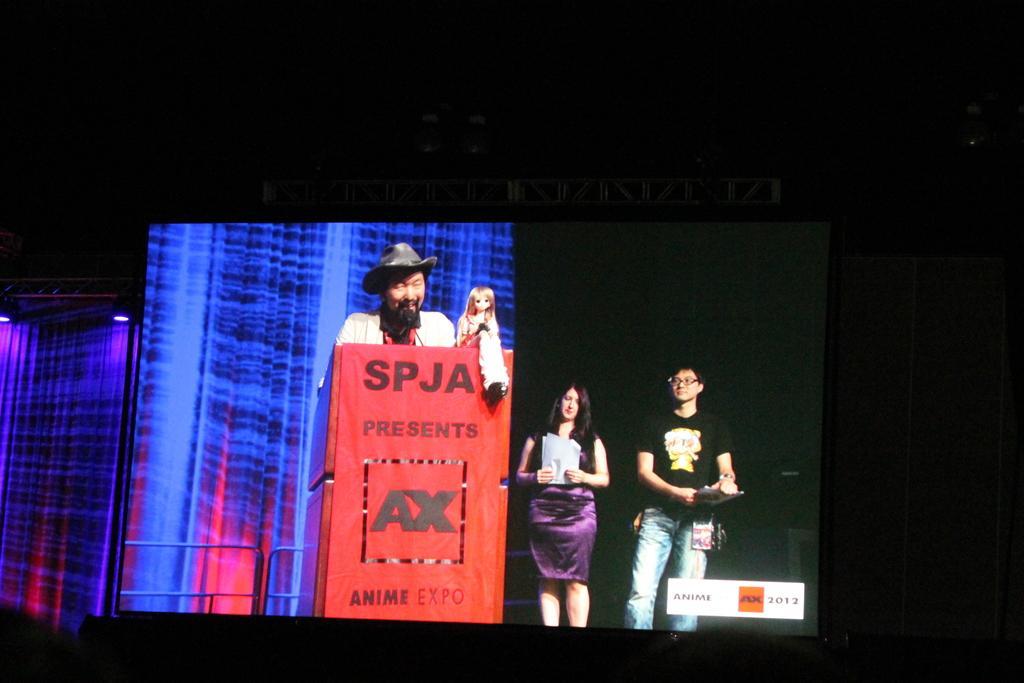In one or two sentences, can you explain what this image depicts? In this image I can see a screen. On the screen there is a man standing in front of the podium. On the podium there is a doll. On the left side of the screen I can see few lights. On the right side of the screen a man and a woman are standing and they are holding some papers in their hands. The background of this image is in black color. 